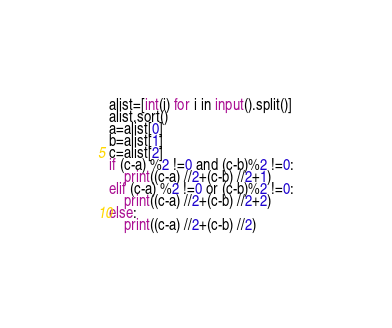<code> <loc_0><loc_0><loc_500><loc_500><_Python_>alist=[int(i) for i in input().split()]
alist.sort()
a=alist[0]
b=alist[1]
c=alist[2]
if (c-a) %2 !=0 and (c-b)%2 !=0:
	print((c-a) //2+(c-b) //2+1)
elif (c-a) %2 !=0 or (c-b)%2 !=0:
	print((c-a) //2+(c-b) //2+2)
else:
	print((c-a) //2+(c-b) //2)</code> 